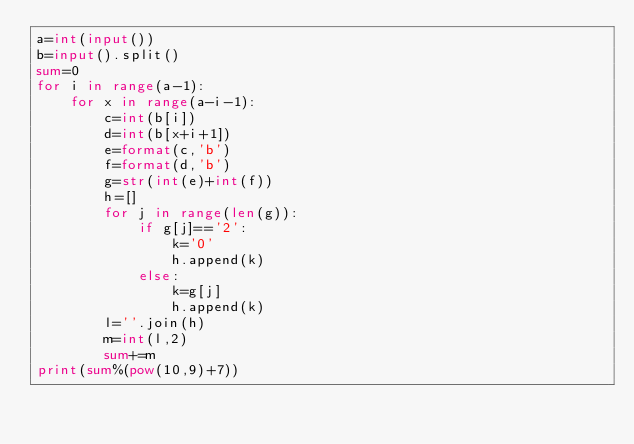<code> <loc_0><loc_0><loc_500><loc_500><_Python_>a=int(input())
b=input().split()
sum=0
for i in range(a-1):
    for x in range(a-i-1):
        c=int(b[i])
        d=int(b[x+i+1])
        e=format(c,'b')
        f=format(d,'b')
        g=str(int(e)+int(f))
        h=[]
        for j in range(len(g)):
            if g[j]=='2':
                k='0'
                h.append(k)
            else:
                k=g[j]
                h.append(k)
        l=''.join(h)
        m=int(l,2)
        sum+=m
print(sum%(pow(10,9)+7))
</code> 